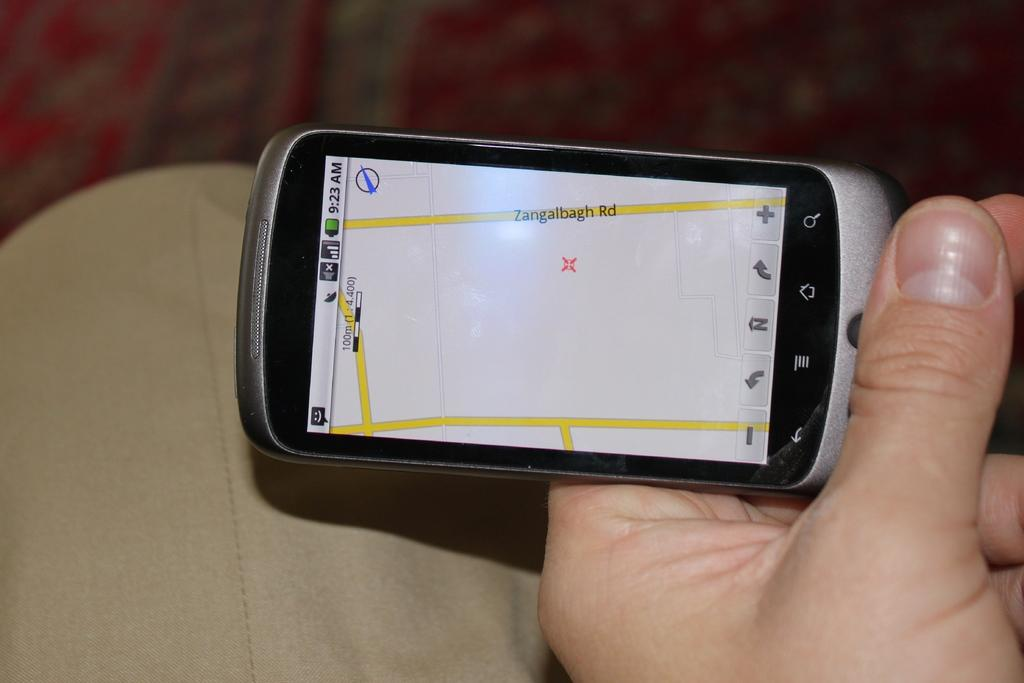<image>
Offer a succinct explanation of the picture presented. A phone shows a time of 9:23 on the screen. 